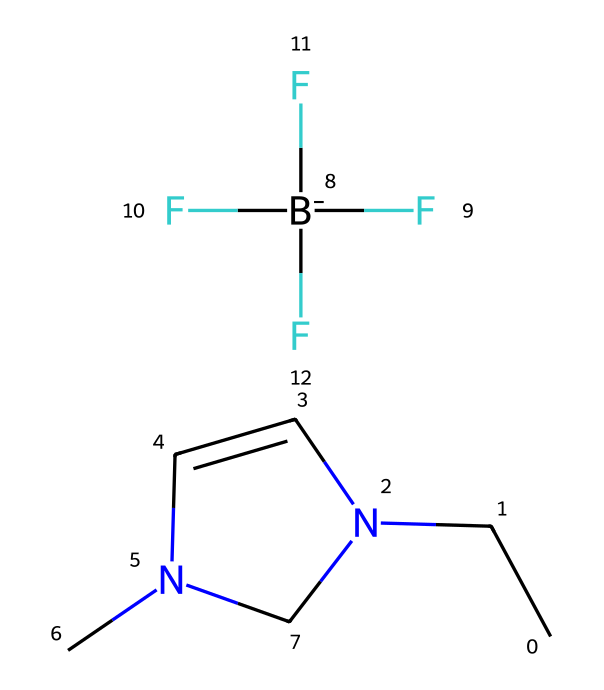What is the chemical name of this compound? The SMILES representation indicates specific components: "CCN1C=CN(C)C1" describes a structure with nitrogen atoms and a distinctive arrangement, which identifies it as a specific ionic liquid. The presence of the tetrafuoroborate anion "[B-](F)(F)(F)F" suggests that the full name is 1-butyl-3-methylimidazolium tetrafluoroborate.
Answer: 1-butyl-3-methylimidazolium tetrafluoroborate How many nitrogen atoms are present in this chemical? By examining the SMILES string, both the part "N1" in the imidazolium ring and another "N" in the structure note the locations of nitrogen atoms, totaling two nitrogen atoms in the structure.
Answer: 2 What is the type of anion associated with this ionic liquid? The presence of "[B-](F)(F)(F)F" in the SMILES structure indicates that the anion is a tetrafuoroborate ion, which is characteristic of ionic liquids.
Answer: tetrafuoroborate Does this ionic liquid contain any aromatic or heterocyclic structures? The structure contains an imidazolium ring, which is both heterocyclic (because it includes nitrogen) and aromatic due to its cyclic nature. This can be identified by the arrangement of nitrogen and carbon atoms in a ring.
Answer: yes What is the primary application of this ionic liquid in cooling systems? Ionic liquids like this compound are used in advanced cooling systems for their excellent thermal stability and low volatility, which are crucial for high-performance gaming PCs where efficient heat management is required.
Answer: cooling 